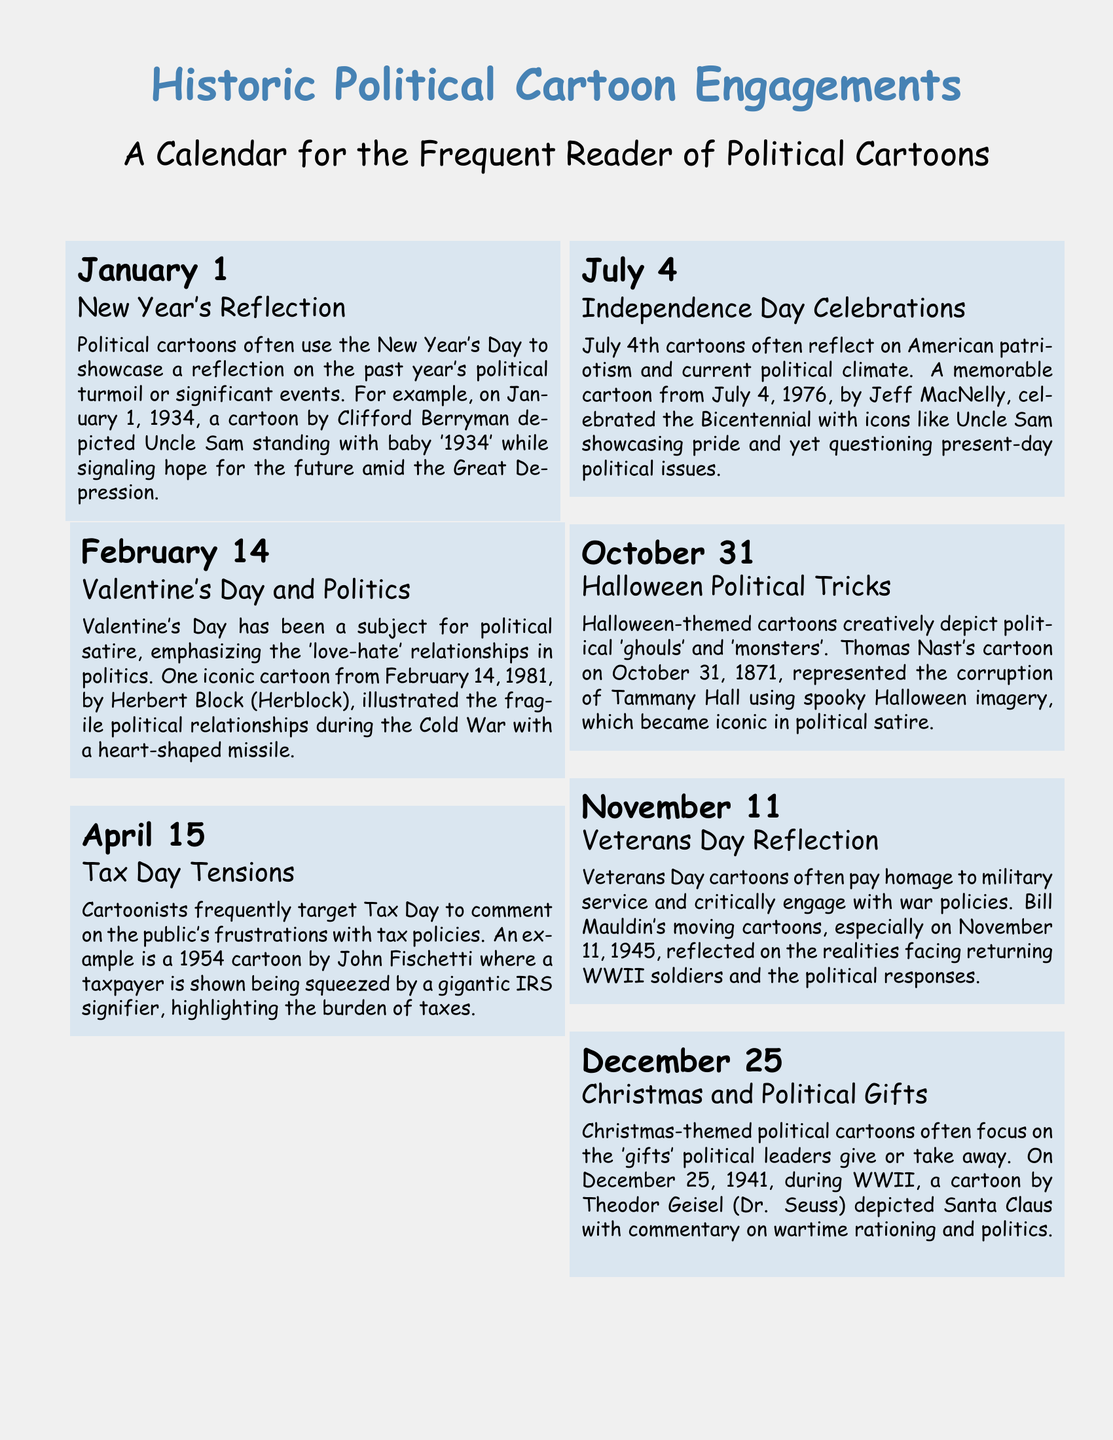What political cartoon is associated with New Year's Day? The entry for January 1 highlights a cartoon by Clifford Berryman that depicted Uncle Sam with baby '1934', emphasizing hope for the future.
Answer: Clifford Berryman What date features a cartoon about Valentine's Day and politics? The calendar entry for Valentine's Day lists February 14 as the date featuring a political cartoon by Herbert Block illustrating fragile relationships during the Cold War.
Answer: February 14 Which political cartoonist created a work for tax day in 1954? The Tax Day entry notes that John Fischetti created a cartoon targeting public frustration with tax policies in 1954.
Answer: John Fischetti What significant event does Independence Day represent in political cartoons? The description for July 4 mentions that these cartoons reflect on American patriotism and current political issues, especially during the Bicentennial in 1976.
Answer: Bicentennial What theme is associated with Halloween political cartoons? The entry for October 31 describes how these cartoons creatively depict political 'ghouls' and 'monsters.'
Answer: Political 'ghouls' and 'monsters' On which date did Bill Mauldin create a reflection on Veterans Day? The document states that Bill Mauldin's significant cartoons related to Veterans Day were on November 11, 1945.
Answer: November 11 Which cartoonist commented on wartime rationing during Christmas in 1941? The Christmas-themed entry mentions that Theodor Geisel (Dr. Seuss) created a cartoon related to wartime rationing on December 25, 1941.
Answer: Theodor Geisel What year did the problematic IRS cartoon by John Fischetti appear? The description for Tax Day references the year 1954 for John Fischetti's cartoon addressing taxpayers' frustrations.
Answer: 1954 